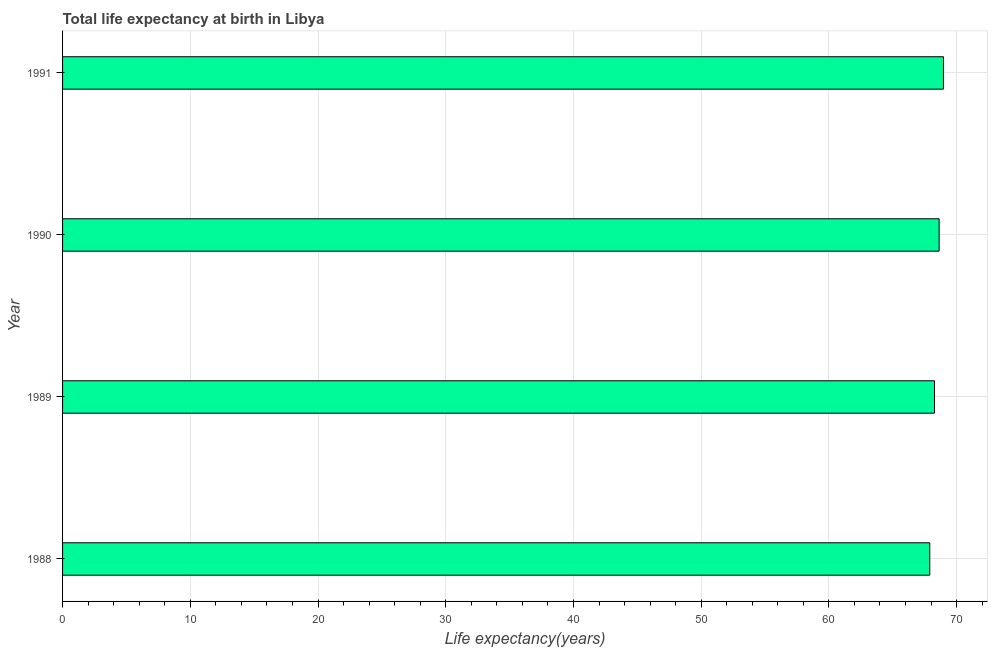Does the graph contain any zero values?
Your answer should be very brief. No. What is the title of the graph?
Make the answer very short. Total life expectancy at birth in Libya. What is the label or title of the X-axis?
Offer a very short reply. Life expectancy(years). What is the label or title of the Y-axis?
Your response must be concise. Year. What is the life expectancy at birth in 1990?
Give a very brief answer. 68.63. Across all years, what is the maximum life expectancy at birth?
Offer a terse response. 68.97. Across all years, what is the minimum life expectancy at birth?
Offer a very short reply. 67.9. What is the sum of the life expectancy at birth?
Your response must be concise. 273.77. What is the difference between the life expectancy at birth in 1988 and 1990?
Your answer should be very brief. -0.73. What is the average life expectancy at birth per year?
Offer a very short reply. 68.44. What is the median life expectancy at birth?
Provide a succinct answer. 68.45. Do a majority of the years between 1991 and 1989 (inclusive) have life expectancy at birth greater than 32 years?
Give a very brief answer. Yes. What is the ratio of the life expectancy at birth in 1988 to that in 1990?
Offer a terse response. 0.99. Is the life expectancy at birth in 1989 less than that in 1991?
Provide a short and direct response. Yes. Is the difference between the life expectancy at birth in 1989 and 1990 greater than the difference between any two years?
Give a very brief answer. No. What is the difference between the highest and the second highest life expectancy at birth?
Ensure brevity in your answer.  0.34. What is the difference between the highest and the lowest life expectancy at birth?
Your response must be concise. 1.07. In how many years, is the life expectancy at birth greater than the average life expectancy at birth taken over all years?
Your answer should be very brief. 2. How many bars are there?
Keep it short and to the point. 4. What is the difference between two consecutive major ticks on the X-axis?
Provide a succinct answer. 10. What is the Life expectancy(years) of 1988?
Offer a terse response. 67.9. What is the Life expectancy(years) of 1989?
Make the answer very short. 68.27. What is the Life expectancy(years) in 1990?
Make the answer very short. 68.63. What is the Life expectancy(years) in 1991?
Ensure brevity in your answer.  68.97. What is the difference between the Life expectancy(years) in 1988 and 1989?
Offer a terse response. -0.37. What is the difference between the Life expectancy(years) in 1988 and 1990?
Give a very brief answer. -0.73. What is the difference between the Life expectancy(years) in 1988 and 1991?
Ensure brevity in your answer.  -1.07. What is the difference between the Life expectancy(years) in 1989 and 1990?
Give a very brief answer. -0.36. What is the difference between the Life expectancy(years) in 1989 and 1991?
Provide a succinct answer. -0.7. What is the difference between the Life expectancy(years) in 1990 and 1991?
Your response must be concise. -0.34. What is the ratio of the Life expectancy(years) in 1988 to that in 1990?
Give a very brief answer. 0.99. What is the ratio of the Life expectancy(years) in 1988 to that in 1991?
Your response must be concise. 0.98. What is the ratio of the Life expectancy(years) in 1989 to that in 1991?
Your response must be concise. 0.99. 